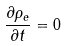<formula> <loc_0><loc_0><loc_500><loc_500>\frac { \partial \rho _ { e } } { \partial t } = 0</formula> 